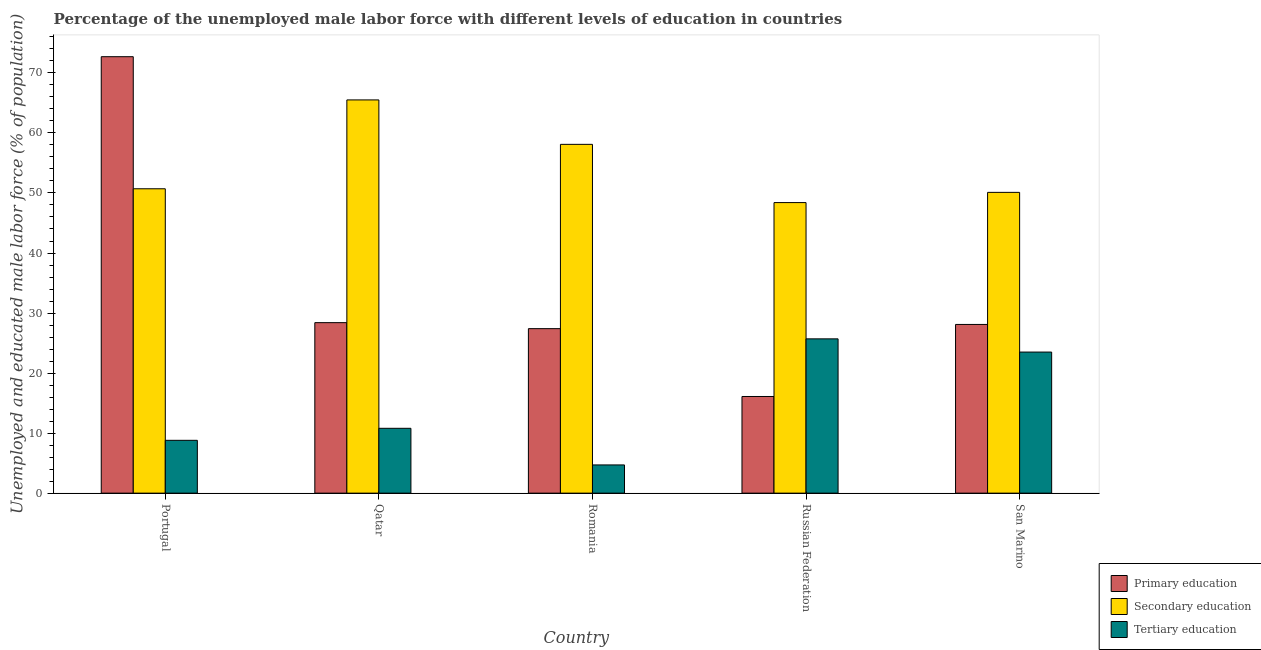How many bars are there on the 3rd tick from the left?
Your answer should be very brief. 3. How many bars are there on the 4th tick from the right?
Give a very brief answer. 3. What is the label of the 4th group of bars from the left?
Ensure brevity in your answer.  Russian Federation. In how many cases, is the number of bars for a given country not equal to the number of legend labels?
Offer a terse response. 0. What is the percentage of male labor force who received tertiary education in Romania?
Your response must be concise. 4.7. Across all countries, what is the maximum percentage of male labor force who received secondary education?
Make the answer very short. 65.5. Across all countries, what is the minimum percentage of male labor force who received tertiary education?
Provide a short and direct response. 4.7. In which country was the percentage of male labor force who received tertiary education minimum?
Give a very brief answer. Romania. What is the total percentage of male labor force who received tertiary education in the graph?
Offer a terse response. 73.5. What is the difference between the percentage of male labor force who received primary education in Romania and that in Russian Federation?
Provide a succinct answer. 11.3. What is the difference between the percentage of male labor force who received secondary education in Qatar and the percentage of male labor force who received tertiary education in Russian Federation?
Your answer should be very brief. 39.8. What is the average percentage of male labor force who received primary education per country?
Ensure brevity in your answer.  34.54. What is the difference between the percentage of male labor force who received tertiary education and percentage of male labor force who received primary education in Qatar?
Give a very brief answer. -17.6. What is the ratio of the percentage of male labor force who received secondary education in Portugal to that in San Marino?
Your response must be concise. 1.01. Is the percentage of male labor force who received secondary education in Romania less than that in Russian Federation?
Your answer should be compact. No. Is the difference between the percentage of male labor force who received primary education in Qatar and Russian Federation greater than the difference between the percentage of male labor force who received secondary education in Qatar and Russian Federation?
Your answer should be compact. No. What is the difference between the highest and the second highest percentage of male labor force who received primary education?
Offer a very short reply. 44.3. What is the difference between the highest and the lowest percentage of male labor force who received primary education?
Your answer should be very brief. 56.6. Is the sum of the percentage of male labor force who received primary education in Qatar and San Marino greater than the maximum percentage of male labor force who received tertiary education across all countries?
Give a very brief answer. Yes. What does the 1st bar from the left in Qatar represents?
Provide a short and direct response. Primary education. What does the 1st bar from the right in San Marino represents?
Offer a terse response. Tertiary education. How many bars are there?
Provide a succinct answer. 15. Does the graph contain any zero values?
Keep it short and to the point. No. Does the graph contain grids?
Provide a succinct answer. No. Where does the legend appear in the graph?
Your answer should be very brief. Bottom right. How many legend labels are there?
Offer a very short reply. 3. What is the title of the graph?
Offer a terse response. Percentage of the unemployed male labor force with different levels of education in countries. Does "Consumption Tax" appear as one of the legend labels in the graph?
Give a very brief answer. No. What is the label or title of the Y-axis?
Ensure brevity in your answer.  Unemployed and educated male labor force (% of population). What is the Unemployed and educated male labor force (% of population) in Primary education in Portugal?
Your answer should be compact. 72.7. What is the Unemployed and educated male labor force (% of population) of Secondary education in Portugal?
Provide a succinct answer. 50.7. What is the Unemployed and educated male labor force (% of population) in Tertiary education in Portugal?
Your answer should be very brief. 8.8. What is the Unemployed and educated male labor force (% of population) of Primary education in Qatar?
Make the answer very short. 28.4. What is the Unemployed and educated male labor force (% of population) in Secondary education in Qatar?
Ensure brevity in your answer.  65.5. What is the Unemployed and educated male labor force (% of population) in Tertiary education in Qatar?
Offer a terse response. 10.8. What is the Unemployed and educated male labor force (% of population) in Primary education in Romania?
Give a very brief answer. 27.4. What is the Unemployed and educated male labor force (% of population) in Secondary education in Romania?
Your answer should be compact. 58.1. What is the Unemployed and educated male labor force (% of population) of Tertiary education in Romania?
Provide a succinct answer. 4.7. What is the Unemployed and educated male labor force (% of population) of Primary education in Russian Federation?
Your response must be concise. 16.1. What is the Unemployed and educated male labor force (% of population) in Secondary education in Russian Federation?
Ensure brevity in your answer.  48.4. What is the Unemployed and educated male labor force (% of population) in Tertiary education in Russian Federation?
Make the answer very short. 25.7. What is the Unemployed and educated male labor force (% of population) of Primary education in San Marino?
Your response must be concise. 28.1. What is the Unemployed and educated male labor force (% of population) of Secondary education in San Marino?
Your answer should be very brief. 50.1. What is the Unemployed and educated male labor force (% of population) of Tertiary education in San Marino?
Give a very brief answer. 23.5. Across all countries, what is the maximum Unemployed and educated male labor force (% of population) in Primary education?
Your response must be concise. 72.7. Across all countries, what is the maximum Unemployed and educated male labor force (% of population) in Secondary education?
Your answer should be very brief. 65.5. Across all countries, what is the maximum Unemployed and educated male labor force (% of population) in Tertiary education?
Make the answer very short. 25.7. Across all countries, what is the minimum Unemployed and educated male labor force (% of population) in Primary education?
Offer a terse response. 16.1. Across all countries, what is the minimum Unemployed and educated male labor force (% of population) in Secondary education?
Your answer should be compact. 48.4. Across all countries, what is the minimum Unemployed and educated male labor force (% of population) in Tertiary education?
Your response must be concise. 4.7. What is the total Unemployed and educated male labor force (% of population) of Primary education in the graph?
Provide a succinct answer. 172.7. What is the total Unemployed and educated male labor force (% of population) of Secondary education in the graph?
Make the answer very short. 272.8. What is the total Unemployed and educated male labor force (% of population) in Tertiary education in the graph?
Keep it short and to the point. 73.5. What is the difference between the Unemployed and educated male labor force (% of population) in Primary education in Portugal and that in Qatar?
Ensure brevity in your answer.  44.3. What is the difference between the Unemployed and educated male labor force (% of population) in Secondary education in Portugal and that in Qatar?
Make the answer very short. -14.8. What is the difference between the Unemployed and educated male labor force (% of population) of Primary education in Portugal and that in Romania?
Provide a short and direct response. 45.3. What is the difference between the Unemployed and educated male labor force (% of population) of Primary education in Portugal and that in Russian Federation?
Provide a short and direct response. 56.6. What is the difference between the Unemployed and educated male labor force (% of population) in Tertiary education in Portugal and that in Russian Federation?
Give a very brief answer. -16.9. What is the difference between the Unemployed and educated male labor force (% of population) of Primary education in Portugal and that in San Marino?
Provide a succinct answer. 44.6. What is the difference between the Unemployed and educated male labor force (% of population) in Tertiary education in Portugal and that in San Marino?
Your response must be concise. -14.7. What is the difference between the Unemployed and educated male labor force (% of population) of Primary education in Qatar and that in Romania?
Provide a succinct answer. 1. What is the difference between the Unemployed and educated male labor force (% of population) of Secondary education in Qatar and that in Romania?
Offer a terse response. 7.4. What is the difference between the Unemployed and educated male labor force (% of population) of Tertiary education in Qatar and that in Russian Federation?
Make the answer very short. -14.9. What is the difference between the Unemployed and educated male labor force (% of population) in Primary education in Qatar and that in San Marino?
Make the answer very short. 0.3. What is the difference between the Unemployed and educated male labor force (% of population) of Secondary education in Qatar and that in San Marino?
Give a very brief answer. 15.4. What is the difference between the Unemployed and educated male labor force (% of population) in Tertiary education in Qatar and that in San Marino?
Provide a succinct answer. -12.7. What is the difference between the Unemployed and educated male labor force (% of population) in Tertiary education in Romania and that in Russian Federation?
Your answer should be very brief. -21. What is the difference between the Unemployed and educated male labor force (% of population) in Secondary education in Romania and that in San Marino?
Provide a succinct answer. 8. What is the difference between the Unemployed and educated male labor force (% of population) of Tertiary education in Romania and that in San Marino?
Your response must be concise. -18.8. What is the difference between the Unemployed and educated male labor force (% of population) of Primary education in Russian Federation and that in San Marino?
Provide a succinct answer. -12. What is the difference between the Unemployed and educated male labor force (% of population) in Primary education in Portugal and the Unemployed and educated male labor force (% of population) in Secondary education in Qatar?
Your response must be concise. 7.2. What is the difference between the Unemployed and educated male labor force (% of population) in Primary education in Portugal and the Unemployed and educated male labor force (% of population) in Tertiary education in Qatar?
Offer a very short reply. 61.9. What is the difference between the Unemployed and educated male labor force (% of population) in Secondary education in Portugal and the Unemployed and educated male labor force (% of population) in Tertiary education in Qatar?
Offer a very short reply. 39.9. What is the difference between the Unemployed and educated male labor force (% of population) in Primary education in Portugal and the Unemployed and educated male labor force (% of population) in Secondary education in Romania?
Your response must be concise. 14.6. What is the difference between the Unemployed and educated male labor force (% of population) of Secondary education in Portugal and the Unemployed and educated male labor force (% of population) of Tertiary education in Romania?
Provide a short and direct response. 46. What is the difference between the Unemployed and educated male labor force (% of population) of Primary education in Portugal and the Unemployed and educated male labor force (% of population) of Secondary education in Russian Federation?
Offer a very short reply. 24.3. What is the difference between the Unemployed and educated male labor force (% of population) of Primary education in Portugal and the Unemployed and educated male labor force (% of population) of Secondary education in San Marino?
Your answer should be very brief. 22.6. What is the difference between the Unemployed and educated male labor force (% of population) in Primary education in Portugal and the Unemployed and educated male labor force (% of population) in Tertiary education in San Marino?
Provide a succinct answer. 49.2. What is the difference between the Unemployed and educated male labor force (% of population) of Secondary education in Portugal and the Unemployed and educated male labor force (% of population) of Tertiary education in San Marino?
Give a very brief answer. 27.2. What is the difference between the Unemployed and educated male labor force (% of population) in Primary education in Qatar and the Unemployed and educated male labor force (% of population) in Secondary education in Romania?
Your answer should be very brief. -29.7. What is the difference between the Unemployed and educated male labor force (% of population) in Primary education in Qatar and the Unemployed and educated male labor force (% of population) in Tertiary education in Romania?
Keep it short and to the point. 23.7. What is the difference between the Unemployed and educated male labor force (% of population) of Secondary education in Qatar and the Unemployed and educated male labor force (% of population) of Tertiary education in Romania?
Your answer should be very brief. 60.8. What is the difference between the Unemployed and educated male labor force (% of population) in Primary education in Qatar and the Unemployed and educated male labor force (% of population) in Secondary education in Russian Federation?
Offer a very short reply. -20. What is the difference between the Unemployed and educated male labor force (% of population) in Primary education in Qatar and the Unemployed and educated male labor force (% of population) in Tertiary education in Russian Federation?
Provide a short and direct response. 2.7. What is the difference between the Unemployed and educated male labor force (% of population) of Secondary education in Qatar and the Unemployed and educated male labor force (% of population) of Tertiary education in Russian Federation?
Your response must be concise. 39.8. What is the difference between the Unemployed and educated male labor force (% of population) of Primary education in Qatar and the Unemployed and educated male labor force (% of population) of Secondary education in San Marino?
Offer a very short reply. -21.7. What is the difference between the Unemployed and educated male labor force (% of population) in Secondary education in Qatar and the Unemployed and educated male labor force (% of population) in Tertiary education in San Marino?
Ensure brevity in your answer.  42. What is the difference between the Unemployed and educated male labor force (% of population) in Primary education in Romania and the Unemployed and educated male labor force (% of population) in Secondary education in Russian Federation?
Make the answer very short. -21. What is the difference between the Unemployed and educated male labor force (% of population) of Primary education in Romania and the Unemployed and educated male labor force (% of population) of Tertiary education in Russian Federation?
Give a very brief answer. 1.7. What is the difference between the Unemployed and educated male labor force (% of population) in Secondary education in Romania and the Unemployed and educated male labor force (% of population) in Tertiary education in Russian Federation?
Keep it short and to the point. 32.4. What is the difference between the Unemployed and educated male labor force (% of population) of Primary education in Romania and the Unemployed and educated male labor force (% of population) of Secondary education in San Marino?
Offer a very short reply. -22.7. What is the difference between the Unemployed and educated male labor force (% of population) of Secondary education in Romania and the Unemployed and educated male labor force (% of population) of Tertiary education in San Marino?
Keep it short and to the point. 34.6. What is the difference between the Unemployed and educated male labor force (% of population) of Primary education in Russian Federation and the Unemployed and educated male labor force (% of population) of Secondary education in San Marino?
Give a very brief answer. -34. What is the difference between the Unemployed and educated male labor force (% of population) of Secondary education in Russian Federation and the Unemployed and educated male labor force (% of population) of Tertiary education in San Marino?
Your response must be concise. 24.9. What is the average Unemployed and educated male labor force (% of population) in Primary education per country?
Keep it short and to the point. 34.54. What is the average Unemployed and educated male labor force (% of population) in Secondary education per country?
Provide a succinct answer. 54.56. What is the difference between the Unemployed and educated male labor force (% of population) in Primary education and Unemployed and educated male labor force (% of population) in Tertiary education in Portugal?
Ensure brevity in your answer.  63.9. What is the difference between the Unemployed and educated male labor force (% of population) in Secondary education and Unemployed and educated male labor force (% of population) in Tertiary education in Portugal?
Provide a short and direct response. 41.9. What is the difference between the Unemployed and educated male labor force (% of population) in Primary education and Unemployed and educated male labor force (% of population) in Secondary education in Qatar?
Your answer should be very brief. -37.1. What is the difference between the Unemployed and educated male labor force (% of population) of Secondary education and Unemployed and educated male labor force (% of population) of Tertiary education in Qatar?
Keep it short and to the point. 54.7. What is the difference between the Unemployed and educated male labor force (% of population) in Primary education and Unemployed and educated male labor force (% of population) in Secondary education in Romania?
Offer a very short reply. -30.7. What is the difference between the Unemployed and educated male labor force (% of population) of Primary education and Unemployed and educated male labor force (% of population) of Tertiary education in Romania?
Your response must be concise. 22.7. What is the difference between the Unemployed and educated male labor force (% of population) in Secondary education and Unemployed and educated male labor force (% of population) in Tertiary education in Romania?
Your answer should be compact. 53.4. What is the difference between the Unemployed and educated male labor force (% of population) in Primary education and Unemployed and educated male labor force (% of population) in Secondary education in Russian Federation?
Your response must be concise. -32.3. What is the difference between the Unemployed and educated male labor force (% of population) in Secondary education and Unemployed and educated male labor force (% of population) in Tertiary education in Russian Federation?
Provide a short and direct response. 22.7. What is the difference between the Unemployed and educated male labor force (% of population) in Primary education and Unemployed and educated male labor force (% of population) in Tertiary education in San Marino?
Your response must be concise. 4.6. What is the difference between the Unemployed and educated male labor force (% of population) of Secondary education and Unemployed and educated male labor force (% of population) of Tertiary education in San Marino?
Provide a succinct answer. 26.6. What is the ratio of the Unemployed and educated male labor force (% of population) in Primary education in Portugal to that in Qatar?
Provide a short and direct response. 2.56. What is the ratio of the Unemployed and educated male labor force (% of population) of Secondary education in Portugal to that in Qatar?
Provide a succinct answer. 0.77. What is the ratio of the Unemployed and educated male labor force (% of population) in Tertiary education in Portugal to that in Qatar?
Offer a terse response. 0.81. What is the ratio of the Unemployed and educated male labor force (% of population) of Primary education in Portugal to that in Romania?
Ensure brevity in your answer.  2.65. What is the ratio of the Unemployed and educated male labor force (% of population) of Secondary education in Portugal to that in Romania?
Offer a very short reply. 0.87. What is the ratio of the Unemployed and educated male labor force (% of population) of Tertiary education in Portugal to that in Romania?
Make the answer very short. 1.87. What is the ratio of the Unemployed and educated male labor force (% of population) of Primary education in Portugal to that in Russian Federation?
Your answer should be compact. 4.52. What is the ratio of the Unemployed and educated male labor force (% of population) in Secondary education in Portugal to that in Russian Federation?
Keep it short and to the point. 1.05. What is the ratio of the Unemployed and educated male labor force (% of population) in Tertiary education in Portugal to that in Russian Federation?
Your answer should be compact. 0.34. What is the ratio of the Unemployed and educated male labor force (% of population) in Primary education in Portugal to that in San Marino?
Your answer should be compact. 2.59. What is the ratio of the Unemployed and educated male labor force (% of population) of Tertiary education in Portugal to that in San Marino?
Offer a terse response. 0.37. What is the ratio of the Unemployed and educated male labor force (% of population) in Primary education in Qatar to that in Romania?
Keep it short and to the point. 1.04. What is the ratio of the Unemployed and educated male labor force (% of population) in Secondary education in Qatar to that in Romania?
Provide a short and direct response. 1.13. What is the ratio of the Unemployed and educated male labor force (% of population) in Tertiary education in Qatar to that in Romania?
Your answer should be very brief. 2.3. What is the ratio of the Unemployed and educated male labor force (% of population) of Primary education in Qatar to that in Russian Federation?
Your answer should be very brief. 1.76. What is the ratio of the Unemployed and educated male labor force (% of population) of Secondary education in Qatar to that in Russian Federation?
Your answer should be very brief. 1.35. What is the ratio of the Unemployed and educated male labor force (% of population) in Tertiary education in Qatar to that in Russian Federation?
Your answer should be very brief. 0.42. What is the ratio of the Unemployed and educated male labor force (% of population) of Primary education in Qatar to that in San Marino?
Ensure brevity in your answer.  1.01. What is the ratio of the Unemployed and educated male labor force (% of population) of Secondary education in Qatar to that in San Marino?
Offer a very short reply. 1.31. What is the ratio of the Unemployed and educated male labor force (% of population) in Tertiary education in Qatar to that in San Marino?
Provide a succinct answer. 0.46. What is the ratio of the Unemployed and educated male labor force (% of population) in Primary education in Romania to that in Russian Federation?
Your answer should be compact. 1.7. What is the ratio of the Unemployed and educated male labor force (% of population) of Secondary education in Romania to that in Russian Federation?
Make the answer very short. 1.2. What is the ratio of the Unemployed and educated male labor force (% of population) in Tertiary education in Romania to that in Russian Federation?
Your response must be concise. 0.18. What is the ratio of the Unemployed and educated male labor force (% of population) in Primary education in Romania to that in San Marino?
Ensure brevity in your answer.  0.98. What is the ratio of the Unemployed and educated male labor force (% of population) of Secondary education in Romania to that in San Marino?
Your answer should be very brief. 1.16. What is the ratio of the Unemployed and educated male labor force (% of population) in Tertiary education in Romania to that in San Marino?
Give a very brief answer. 0.2. What is the ratio of the Unemployed and educated male labor force (% of population) in Primary education in Russian Federation to that in San Marino?
Provide a succinct answer. 0.57. What is the ratio of the Unemployed and educated male labor force (% of population) of Secondary education in Russian Federation to that in San Marino?
Keep it short and to the point. 0.97. What is the ratio of the Unemployed and educated male labor force (% of population) in Tertiary education in Russian Federation to that in San Marino?
Give a very brief answer. 1.09. What is the difference between the highest and the second highest Unemployed and educated male labor force (% of population) in Primary education?
Your response must be concise. 44.3. What is the difference between the highest and the second highest Unemployed and educated male labor force (% of population) of Secondary education?
Offer a terse response. 7.4. What is the difference between the highest and the second highest Unemployed and educated male labor force (% of population) of Tertiary education?
Offer a terse response. 2.2. What is the difference between the highest and the lowest Unemployed and educated male labor force (% of population) of Primary education?
Keep it short and to the point. 56.6. What is the difference between the highest and the lowest Unemployed and educated male labor force (% of population) of Tertiary education?
Your answer should be compact. 21. 